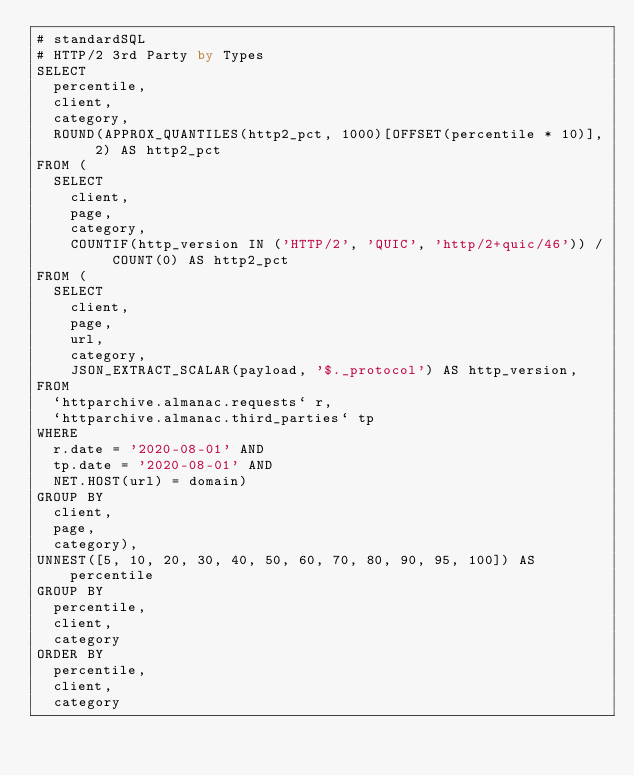Convert code to text. <code><loc_0><loc_0><loc_500><loc_500><_SQL_># standardSQL
# HTTP/2 3rd Party by Types
SELECT
  percentile,
  client,
  category,
  ROUND(APPROX_QUANTILES(http2_pct, 1000)[OFFSET(percentile * 10)], 2) AS http2_pct
FROM (
  SELECT
    client,
    page,
    category,
    COUNTIF(http_version IN ('HTTP/2', 'QUIC', 'http/2+quic/46')) / COUNT(0) AS http2_pct
FROM (
  SELECT
    client,
    page,
    url,
    category,
    JSON_EXTRACT_SCALAR(payload, '$._protocol') AS http_version,
FROM
  `httparchive.almanac.requests` r,
  `httparchive.almanac.third_parties` tp
WHERE
  r.date = '2020-08-01' AND
  tp.date = '2020-08-01' AND
  NET.HOST(url) = domain)
GROUP BY
  client,
  page,
  category),
UNNEST([5, 10, 20, 30, 40, 50, 60, 70, 80, 90, 95, 100]) AS percentile
GROUP BY
  percentile,
  client,
  category
ORDER BY
  percentile,
  client,
  category
</code> 